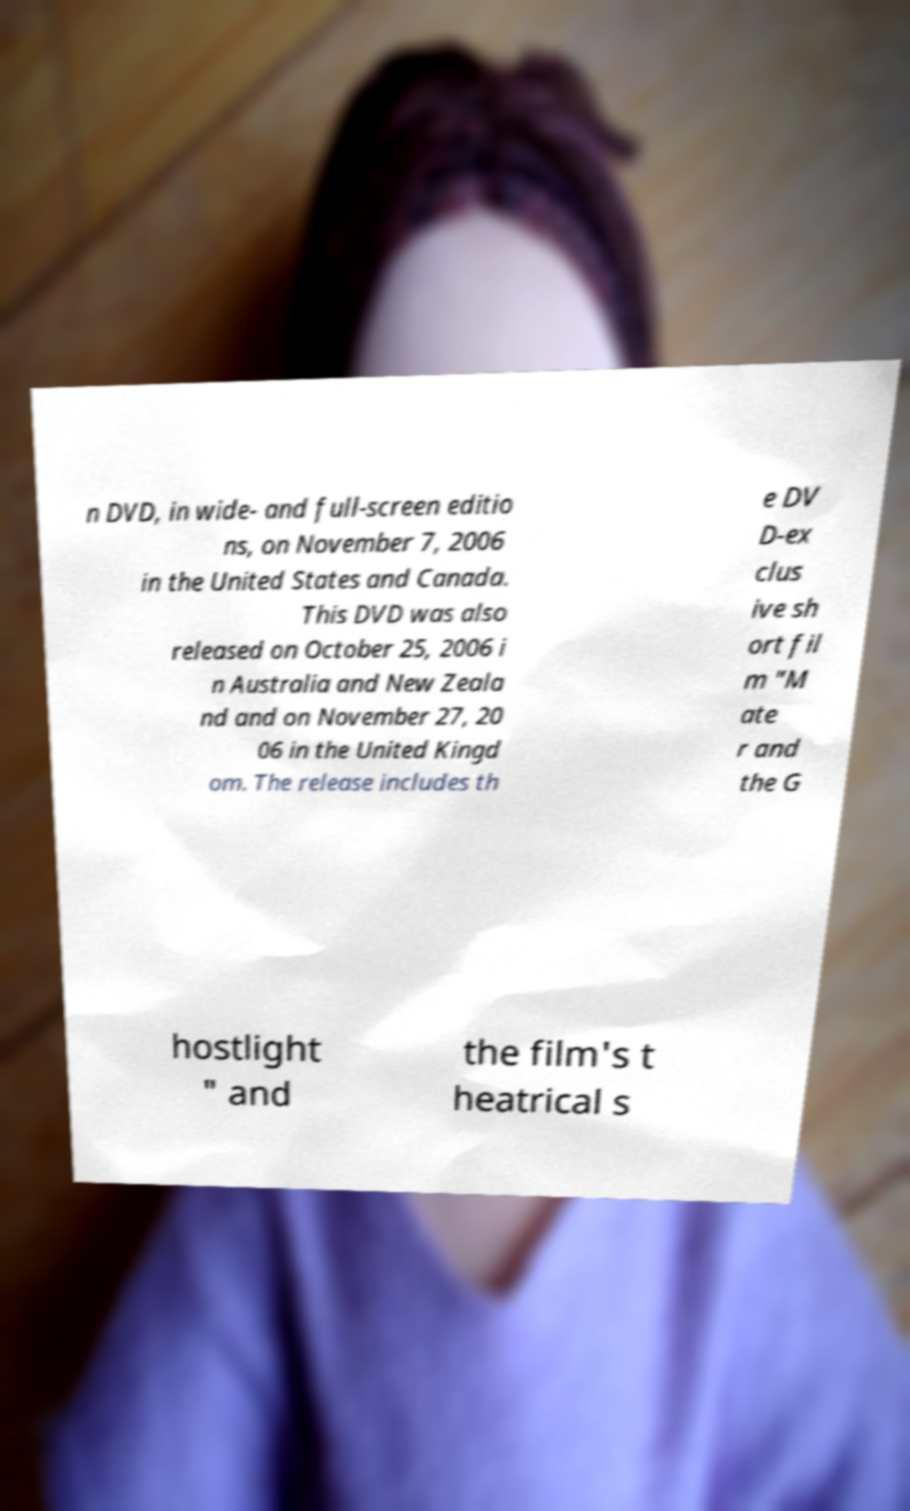Can you accurately transcribe the text from the provided image for me? n DVD, in wide- and full-screen editio ns, on November 7, 2006 in the United States and Canada. This DVD was also released on October 25, 2006 i n Australia and New Zeala nd and on November 27, 20 06 in the United Kingd om. The release includes th e DV D-ex clus ive sh ort fil m "M ate r and the G hostlight " and the film's t heatrical s 